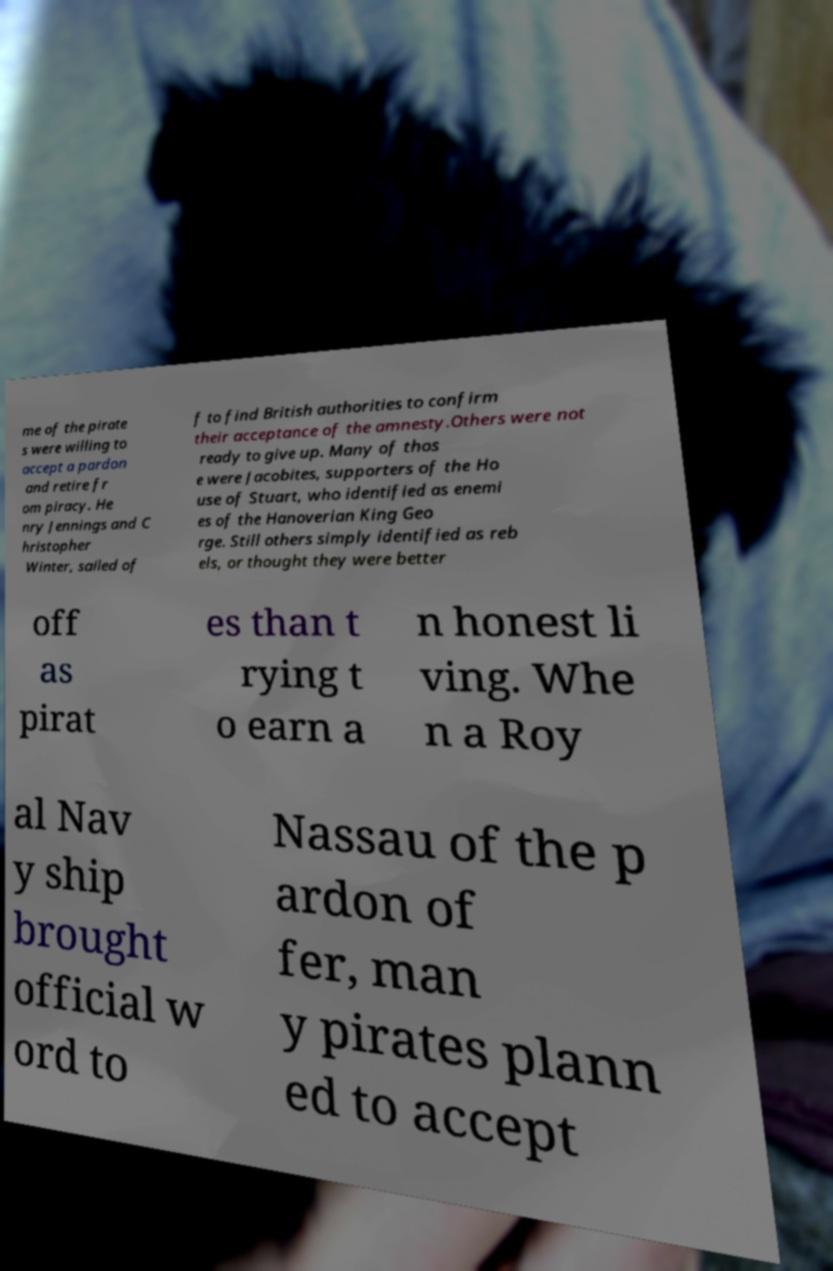Could you assist in decoding the text presented in this image and type it out clearly? me of the pirate s were willing to accept a pardon and retire fr om piracy. He nry Jennings and C hristopher Winter, sailed of f to find British authorities to confirm their acceptance of the amnesty.Others were not ready to give up. Many of thos e were Jacobites, supporters of the Ho use of Stuart, who identified as enemi es of the Hanoverian King Geo rge. Still others simply identified as reb els, or thought they were better off as pirat es than t rying t o earn a n honest li ving. Whe n a Roy al Nav y ship brought official w ord to Nassau of the p ardon of fer, man y pirates plann ed to accept 